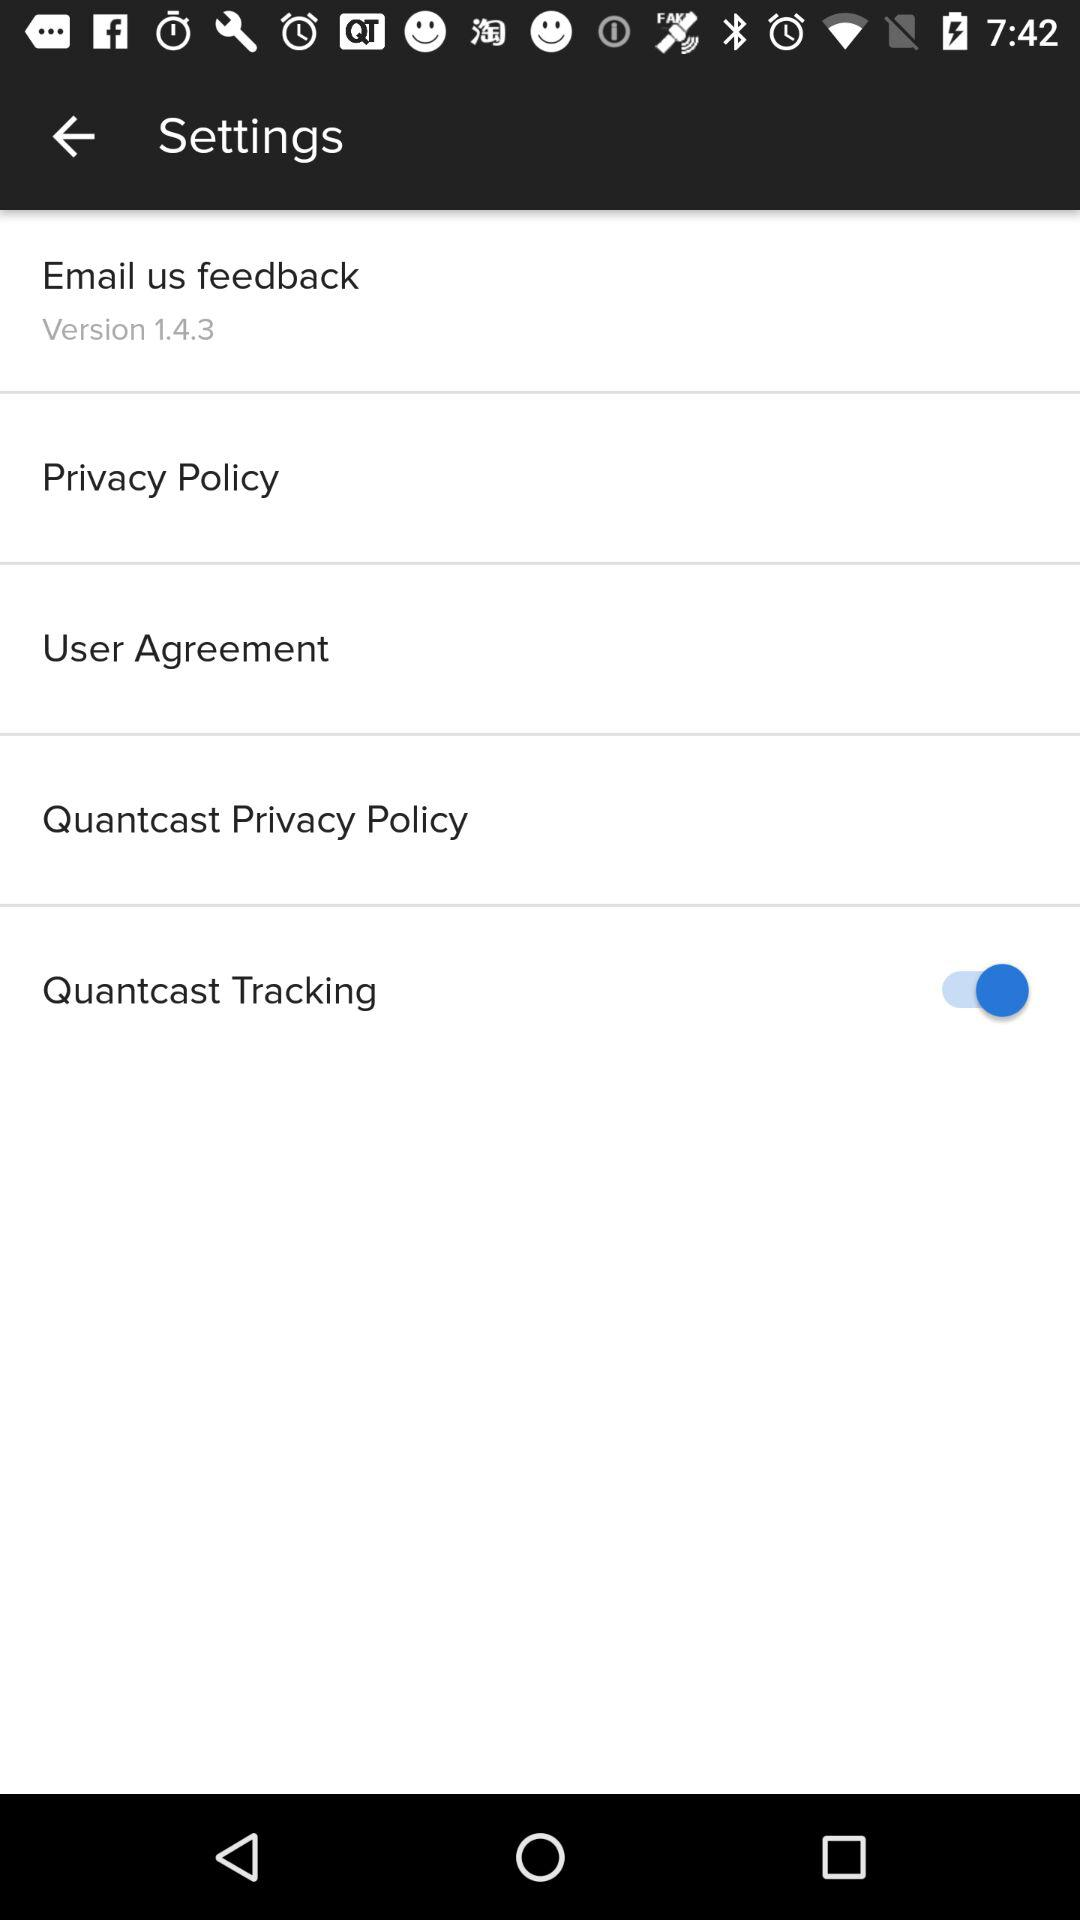How many items are above the Quantcast Tracking item?
Answer the question using a single word or phrase. 4 